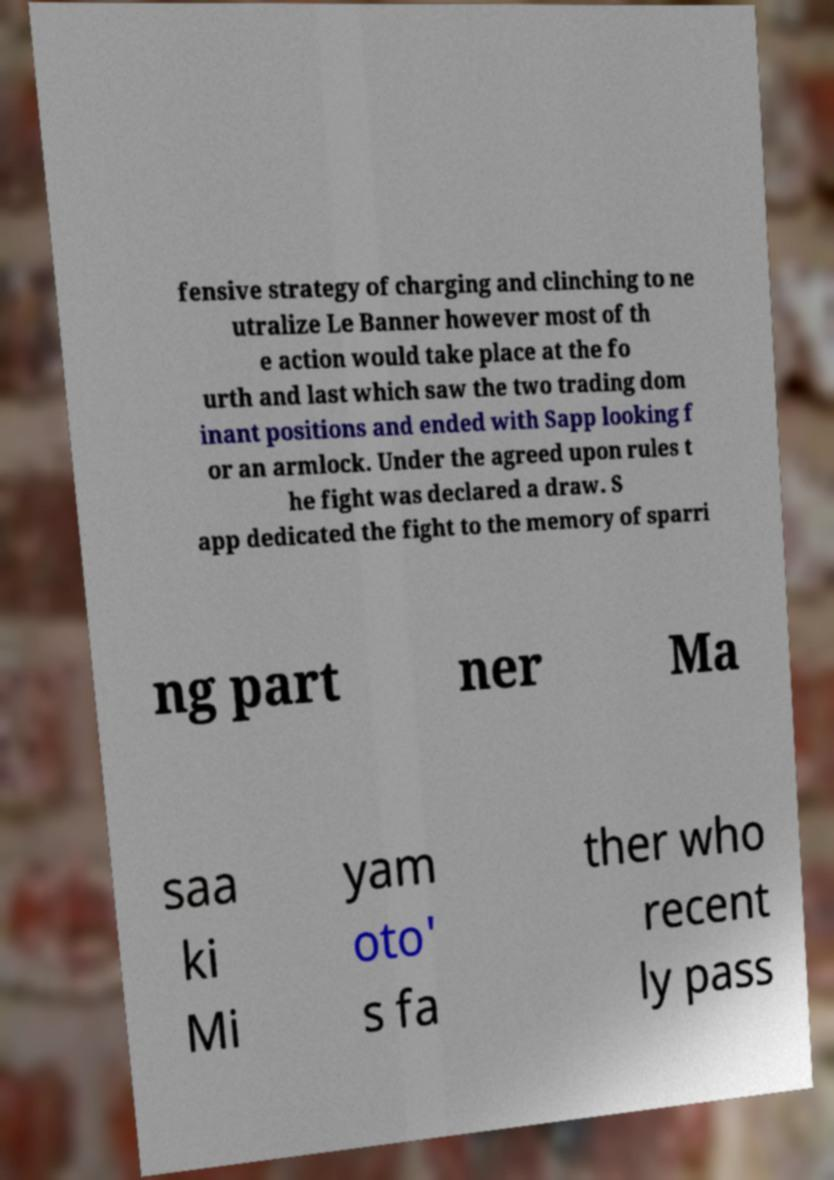Please read and relay the text visible in this image. What does it say? fensive strategy of charging and clinching to ne utralize Le Banner however most of th e action would take place at the fo urth and last which saw the two trading dom inant positions and ended with Sapp looking f or an armlock. Under the agreed upon rules t he fight was declared a draw. S app dedicated the fight to the memory of sparri ng part ner Ma saa ki Mi yam oto' s fa ther who recent ly pass 